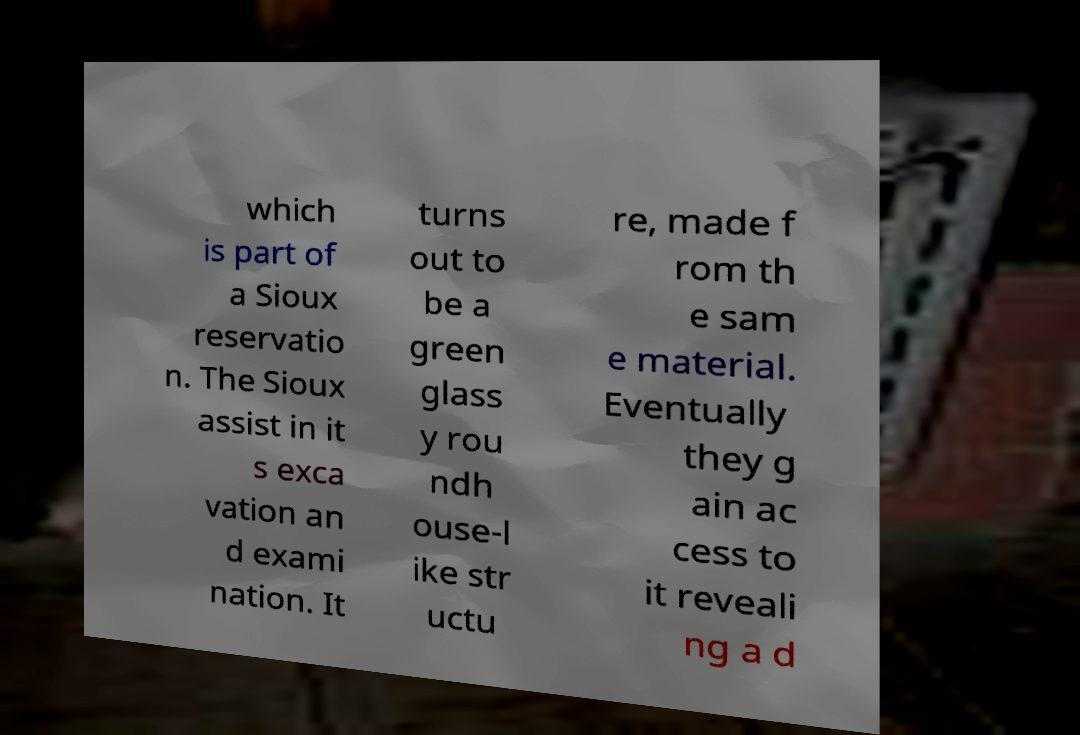What messages or text are displayed in this image? I need them in a readable, typed format. which is part of a Sioux reservatio n. The Sioux assist in it s exca vation an d exami nation. It turns out to be a green glass y rou ndh ouse-l ike str uctu re, made f rom th e sam e material. Eventually they g ain ac cess to it reveali ng a d 